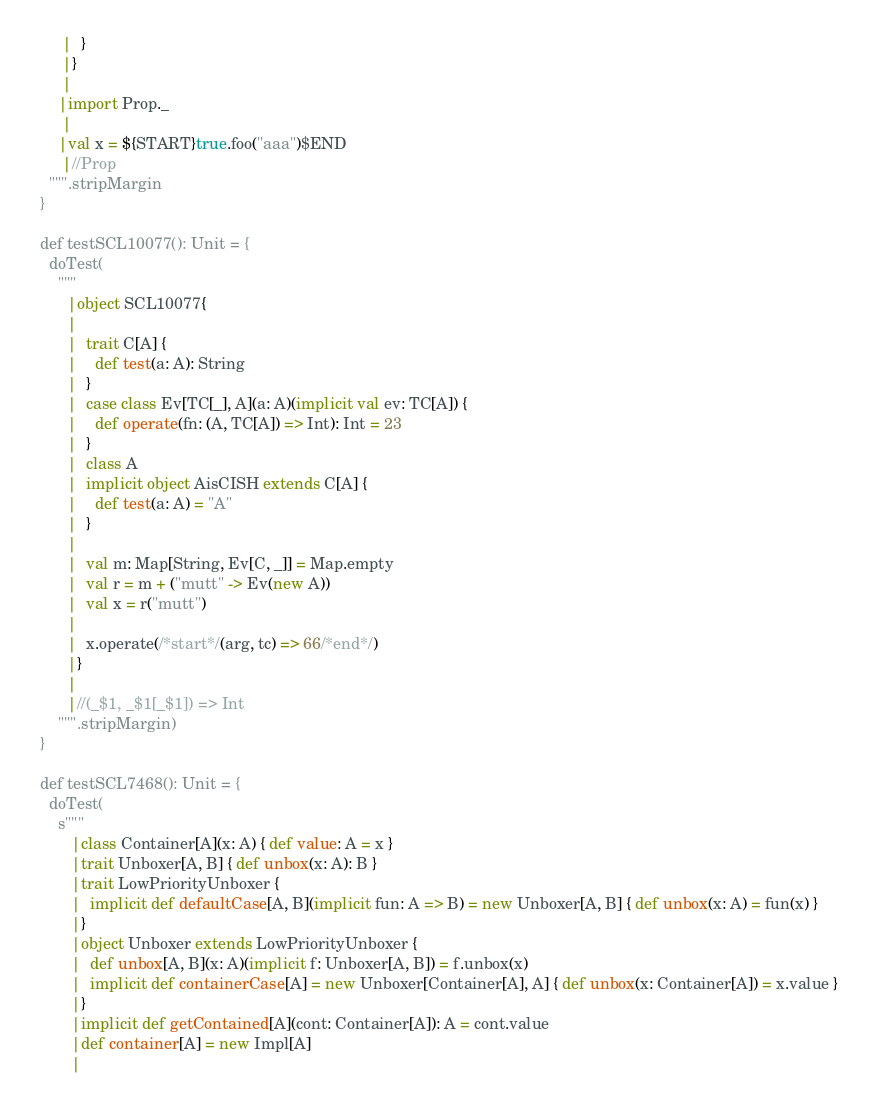<code> <loc_0><loc_0><loc_500><loc_500><_Scala_>       |  }
       |}
       |
      |import Prop._
       |
      |val x = ${START}true.foo("aaa")$END
       |//Prop
    """.stripMargin
  }

  def testSCL10077(): Unit = {
    doTest(
      """
        |object SCL10077{
        |
        |  trait C[A] {
        |    def test(a: A): String
        |  }
        |  case class Ev[TC[_], A](a: A)(implicit val ev: TC[A]) {
        |    def operate(fn: (A, TC[A]) => Int): Int = 23
        |  }
        |  class A
        |  implicit object AisCISH extends C[A] {
        |    def test(a: A) = "A"
        |  }
        |
        |  val m: Map[String, Ev[C, _]] = Map.empty
        |  val r = m + ("mutt" -> Ev(new A))
        |  val x = r("mutt")
        |
        |  x.operate(/*start*/(arg, tc) => 66/*end*/)
        |}
        |
        |//(_$1, _$1[_$1]) => Int
      """.stripMargin)
  }

  def testSCL7468(): Unit = {
    doTest(
      s"""
         |class Container[A](x: A) { def value: A = x }
         |trait Unboxer[A, B] { def unbox(x: A): B }
         |trait LowPriorityUnboxer {
         |  implicit def defaultCase[A, B](implicit fun: A => B) = new Unboxer[A, B] { def unbox(x: A) = fun(x) }
         |}
         |object Unboxer extends LowPriorityUnboxer {
         |  def unbox[A, B](x: A)(implicit f: Unboxer[A, B]) = f.unbox(x)
         |  implicit def containerCase[A] = new Unboxer[Container[A], A] { def unbox(x: Container[A]) = x.value }
         |}
         |implicit def getContained[A](cont: Container[A]): A = cont.value
         |def container[A] = new Impl[A]
         |</code> 